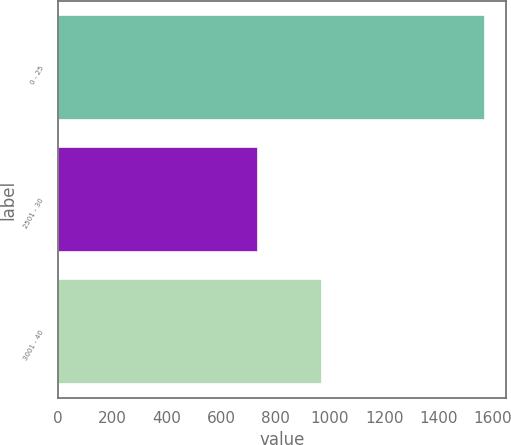<chart> <loc_0><loc_0><loc_500><loc_500><bar_chart><fcel>0 - 25<fcel>2501 - 30<fcel>3001 - 40<nl><fcel>1570<fcel>734<fcel>972<nl></chart> 